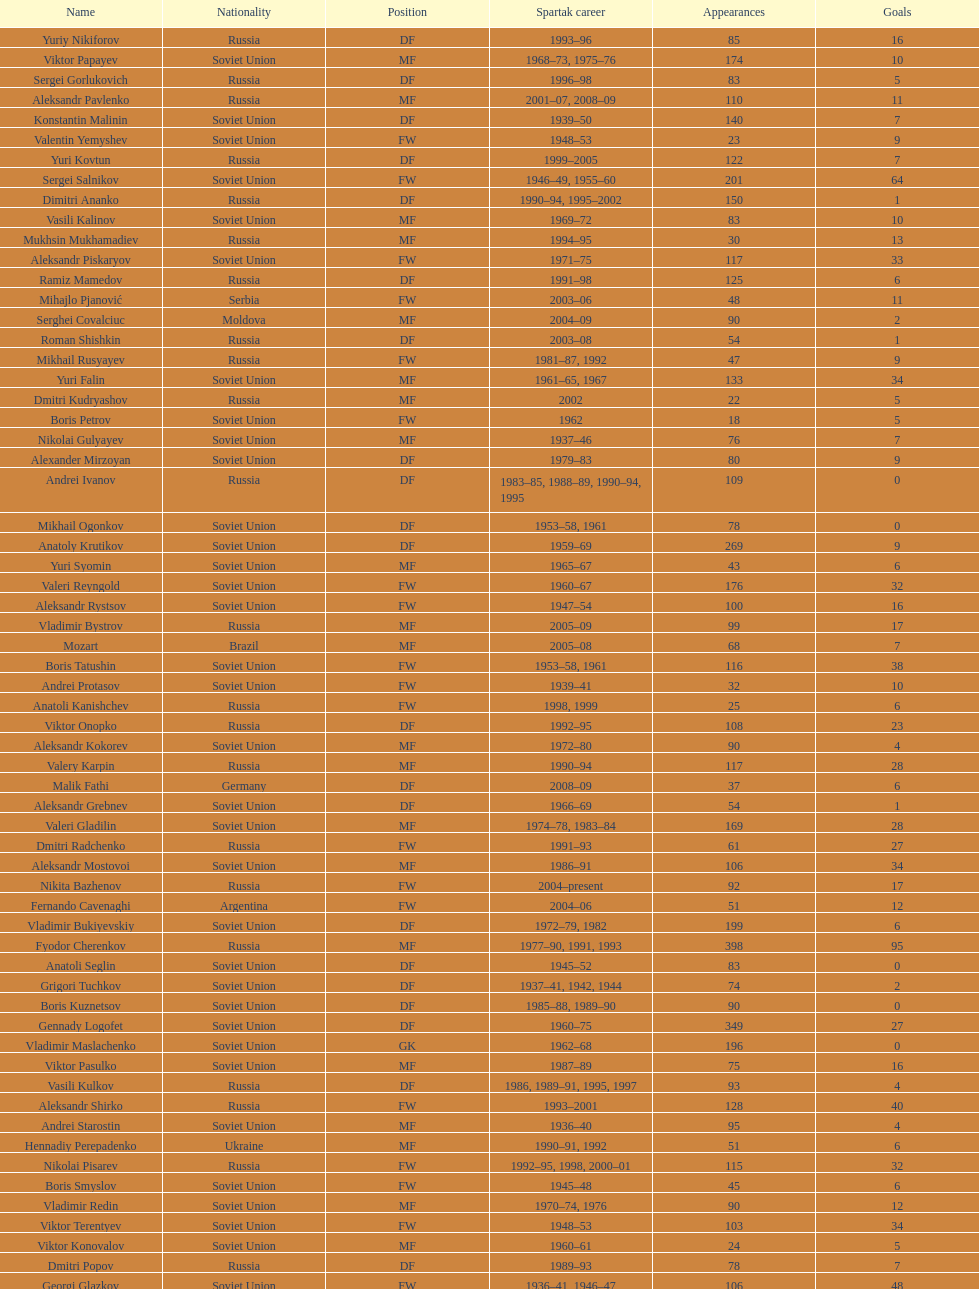Name two players with goals above 15. Dmitri Alenichev, Vyacheslav Ambartsumyan. 